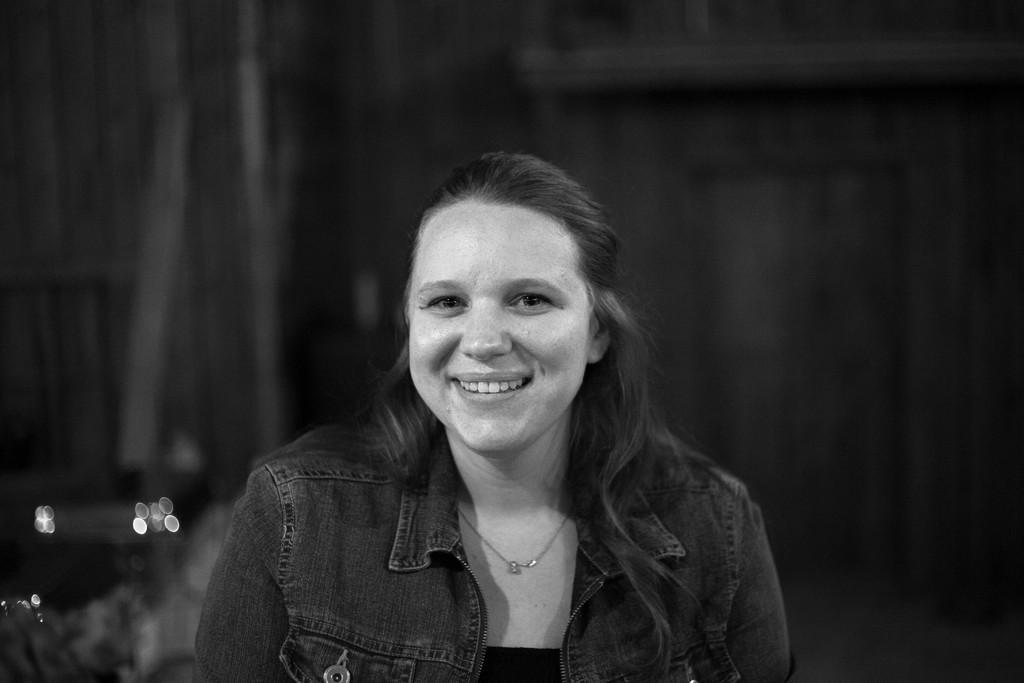In one or two sentences, can you explain what this image depicts? In this image I see a woman who is smiling and I see that she is wearing a locket on her neck and it is dark in the background and I see that this is a black and white image. 